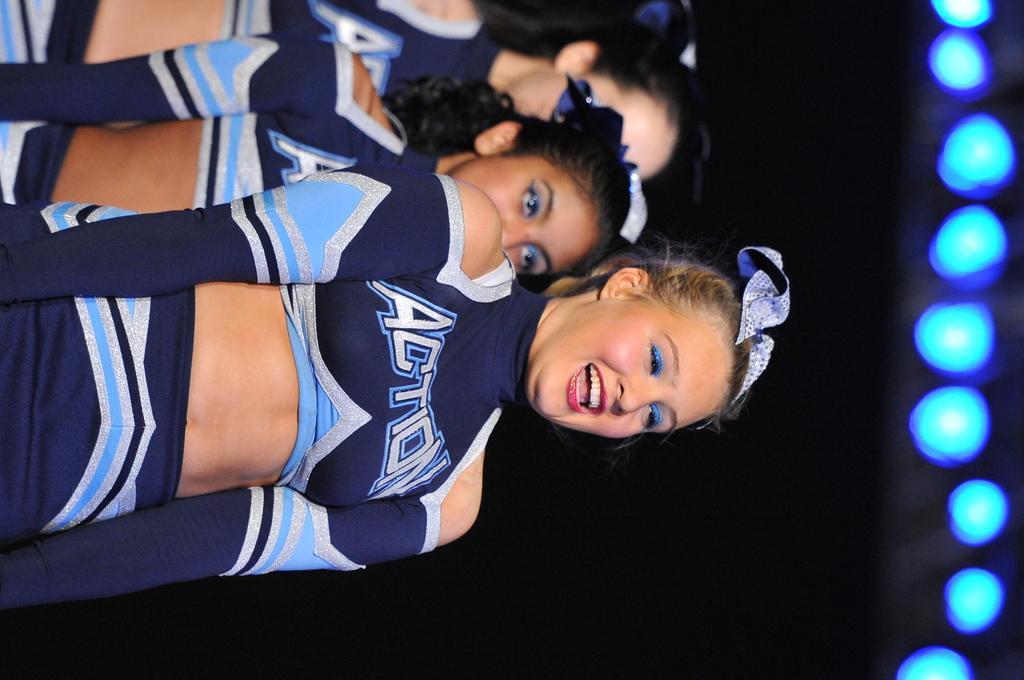How would you summarize this image in a sentence or two? This image is in in right direction. Here I can see three women are wearing blue color dresses, standing and smiling. The background is in black color. On the right side there are some lights. 